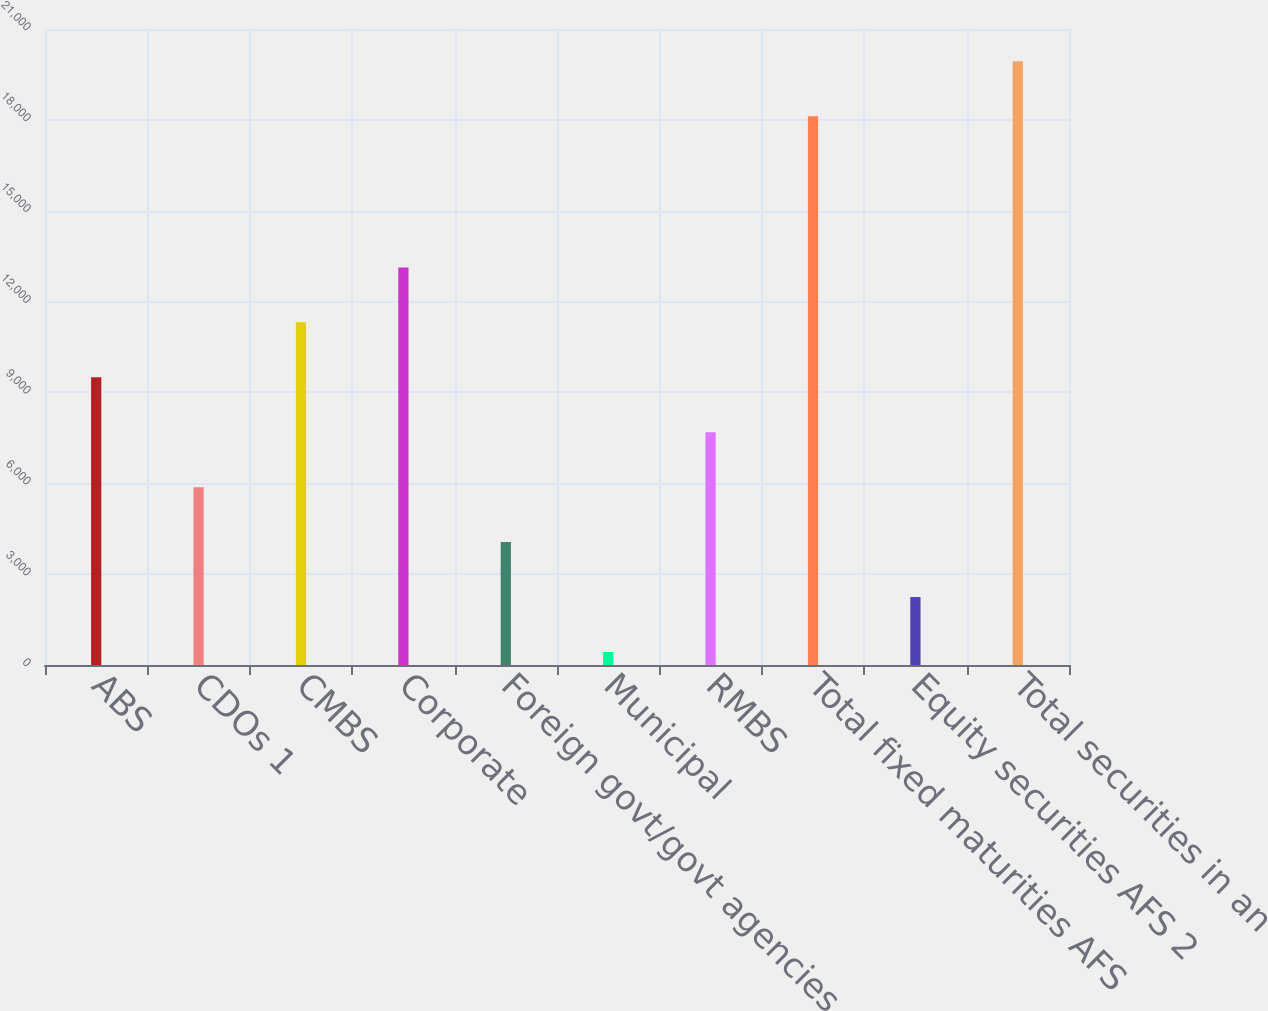Convert chart. <chart><loc_0><loc_0><loc_500><loc_500><bar_chart><fcel>ABS<fcel>CDOs 1<fcel>CMBS<fcel>Corporate<fcel>Foreign govt/govt agencies<fcel>Municipal<fcel>RMBS<fcel>Total fixed maturities AFS<fcel>Equity securities AFS 2<fcel>Total securities in an<nl><fcel>9499.5<fcel>5871.7<fcel>11313.4<fcel>13127.3<fcel>4057.8<fcel>430<fcel>7685.6<fcel>18120<fcel>2243.9<fcel>19933.9<nl></chart> 